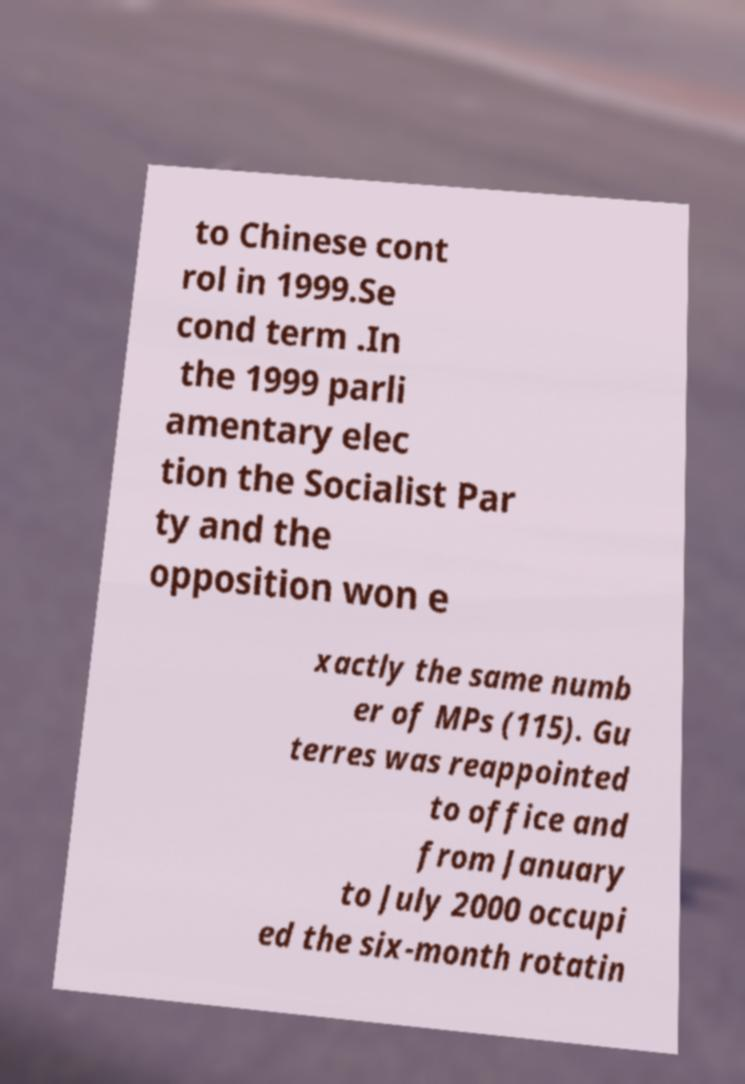Please identify and transcribe the text found in this image. to Chinese cont rol in 1999.Se cond term .In the 1999 parli amentary elec tion the Socialist Par ty and the opposition won e xactly the same numb er of MPs (115). Gu terres was reappointed to office and from January to July 2000 occupi ed the six-month rotatin 